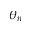<formula> <loc_0><loc_0><loc_500><loc_500>\theta _ { n }</formula> 